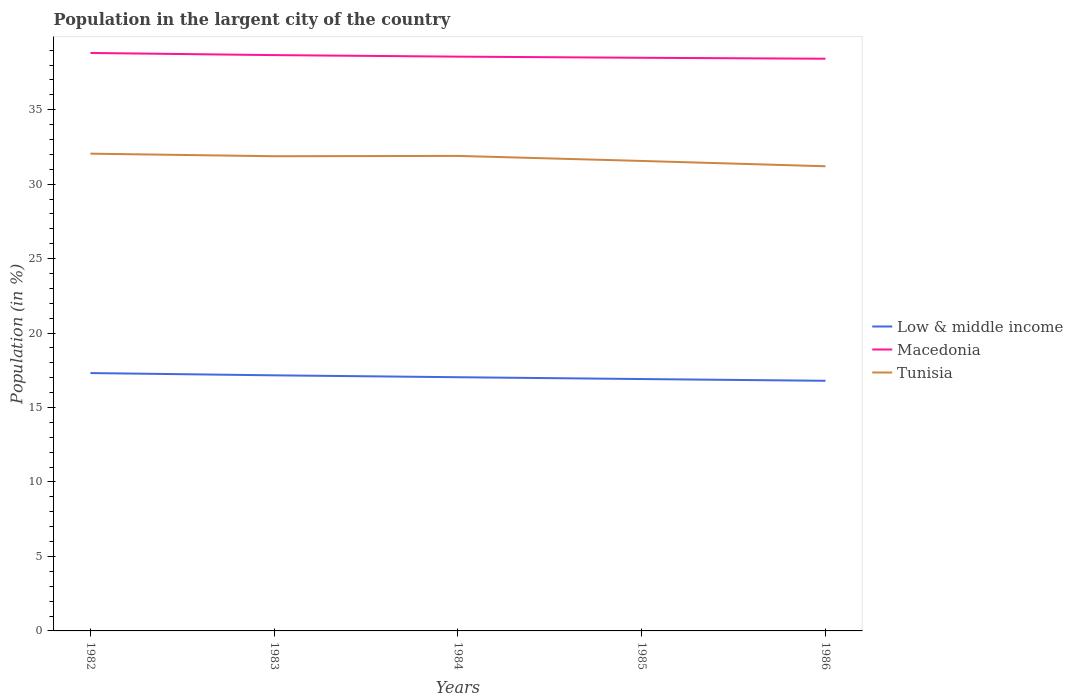Does the line corresponding to Low & middle income intersect with the line corresponding to Tunisia?
Keep it short and to the point. No. Is the number of lines equal to the number of legend labels?
Make the answer very short. Yes. Across all years, what is the maximum percentage of population in the largent city in Low & middle income?
Your answer should be very brief. 16.8. What is the total percentage of population in the largent city in Low & middle income in the graph?
Your answer should be very brief. 0.25. What is the difference between the highest and the second highest percentage of population in the largent city in Low & middle income?
Make the answer very short. 0.52. What is the difference between the highest and the lowest percentage of population in the largent city in Macedonia?
Keep it short and to the point. 2. Is the percentage of population in the largent city in Macedonia strictly greater than the percentage of population in the largent city in Low & middle income over the years?
Provide a succinct answer. No. Are the values on the major ticks of Y-axis written in scientific E-notation?
Ensure brevity in your answer.  No. What is the title of the graph?
Keep it short and to the point. Population in the largent city of the country. What is the label or title of the X-axis?
Ensure brevity in your answer.  Years. What is the label or title of the Y-axis?
Ensure brevity in your answer.  Population (in %). What is the Population (in %) of Low & middle income in 1982?
Provide a short and direct response. 17.31. What is the Population (in %) in Macedonia in 1982?
Make the answer very short. 38.81. What is the Population (in %) of Tunisia in 1982?
Keep it short and to the point. 32.05. What is the Population (in %) in Low & middle income in 1983?
Offer a terse response. 17.16. What is the Population (in %) in Macedonia in 1983?
Offer a very short reply. 38.66. What is the Population (in %) of Tunisia in 1983?
Your answer should be compact. 31.87. What is the Population (in %) in Low & middle income in 1984?
Keep it short and to the point. 17.04. What is the Population (in %) in Macedonia in 1984?
Provide a short and direct response. 38.56. What is the Population (in %) in Tunisia in 1984?
Give a very brief answer. 31.9. What is the Population (in %) of Low & middle income in 1985?
Provide a succinct answer. 16.91. What is the Population (in %) of Macedonia in 1985?
Give a very brief answer. 38.48. What is the Population (in %) in Tunisia in 1985?
Make the answer very short. 31.56. What is the Population (in %) of Low & middle income in 1986?
Give a very brief answer. 16.8. What is the Population (in %) in Macedonia in 1986?
Your response must be concise. 38.42. What is the Population (in %) of Tunisia in 1986?
Ensure brevity in your answer.  31.2. Across all years, what is the maximum Population (in %) of Low & middle income?
Ensure brevity in your answer.  17.31. Across all years, what is the maximum Population (in %) in Macedonia?
Provide a short and direct response. 38.81. Across all years, what is the maximum Population (in %) of Tunisia?
Ensure brevity in your answer.  32.05. Across all years, what is the minimum Population (in %) of Low & middle income?
Give a very brief answer. 16.8. Across all years, what is the minimum Population (in %) of Macedonia?
Ensure brevity in your answer.  38.42. Across all years, what is the minimum Population (in %) of Tunisia?
Provide a succinct answer. 31.2. What is the total Population (in %) of Low & middle income in the graph?
Offer a terse response. 85.22. What is the total Population (in %) of Macedonia in the graph?
Your answer should be very brief. 192.94. What is the total Population (in %) in Tunisia in the graph?
Provide a succinct answer. 158.57. What is the difference between the Population (in %) of Low & middle income in 1982 and that in 1983?
Your response must be concise. 0.15. What is the difference between the Population (in %) of Macedonia in 1982 and that in 1983?
Offer a very short reply. 0.14. What is the difference between the Population (in %) of Tunisia in 1982 and that in 1983?
Offer a terse response. 0.17. What is the difference between the Population (in %) in Low & middle income in 1982 and that in 1984?
Ensure brevity in your answer.  0.28. What is the difference between the Population (in %) of Macedonia in 1982 and that in 1984?
Make the answer very short. 0.25. What is the difference between the Population (in %) in Tunisia in 1982 and that in 1984?
Offer a very short reply. 0.15. What is the difference between the Population (in %) in Low & middle income in 1982 and that in 1985?
Your response must be concise. 0.4. What is the difference between the Population (in %) in Macedonia in 1982 and that in 1985?
Give a very brief answer. 0.32. What is the difference between the Population (in %) of Tunisia in 1982 and that in 1985?
Offer a terse response. 0.49. What is the difference between the Population (in %) in Low & middle income in 1982 and that in 1986?
Make the answer very short. 0.52. What is the difference between the Population (in %) of Macedonia in 1982 and that in 1986?
Give a very brief answer. 0.39. What is the difference between the Population (in %) in Tunisia in 1982 and that in 1986?
Your answer should be very brief. 0.85. What is the difference between the Population (in %) in Low & middle income in 1983 and that in 1984?
Ensure brevity in your answer.  0.13. What is the difference between the Population (in %) of Macedonia in 1983 and that in 1984?
Offer a terse response. 0.1. What is the difference between the Population (in %) in Tunisia in 1983 and that in 1984?
Offer a very short reply. -0.02. What is the difference between the Population (in %) in Low & middle income in 1983 and that in 1985?
Provide a succinct answer. 0.25. What is the difference between the Population (in %) in Macedonia in 1983 and that in 1985?
Your response must be concise. 0.18. What is the difference between the Population (in %) of Tunisia in 1983 and that in 1985?
Ensure brevity in your answer.  0.32. What is the difference between the Population (in %) in Low & middle income in 1983 and that in 1986?
Keep it short and to the point. 0.37. What is the difference between the Population (in %) in Macedonia in 1983 and that in 1986?
Your answer should be compact. 0.24. What is the difference between the Population (in %) in Tunisia in 1983 and that in 1986?
Offer a terse response. 0.67. What is the difference between the Population (in %) of Low & middle income in 1984 and that in 1985?
Your response must be concise. 0.12. What is the difference between the Population (in %) in Macedonia in 1984 and that in 1985?
Provide a short and direct response. 0.08. What is the difference between the Population (in %) in Tunisia in 1984 and that in 1985?
Provide a succinct answer. 0.34. What is the difference between the Population (in %) in Low & middle income in 1984 and that in 1986?
Make the answer very short. 0.24. What is the difference between the Population (in %) of Macedonia in 1984 and that in 1986?
Your response must be concise. 0.14. What is the difference between the Population (in %) in Tunisia in 1984 and that in 1986?
Your answer should be compact. 0.7. What is the difference between the Population (in %) in Low & middle income in 1985 and that in 1986?
Your answer should be compact. 0.12. What is the difference between the Population (in %) in Macedonia in 1985 and that in 1986?
Your response must be concise. 0.06. What is the difference between the Population (in %) in Tunisia in 1985 and that in 1986?
Offer a terse response. 0.36. What is the difference between the Population (in %) in Low & middle income in 1982 and the Population (in %) in Macedonia in 1983?
Give a very brief answer. -21.35. What is the difference between the Population (in %) of Low & middle income in 1982 and the Population (in %) of Tunisia in 1983?
Your response must be concise. -14.56. What is the difference between the Population (in %) in Macedonia in 1982 and the Population (in %) in Tunisia in 1983?
Give a very brief answer. 6.93. What is the difference between the Population (in %) in Low & middle income in 1982 and the Population (in %) in Macedonia in 1984?
Offer a very short reply. -21.25. What is the difference between the Population (in %) in Low & middle income in 1982 and the Population (in %) in Tunisia in 1984?
Ensure brevity in your answer.  -14.58. What is the difference between the Population (in %) in Macedonia in 1982 and the Population (in %) in Tunisia in 1984?
Keep it short and to the point. 6.91. What is the difference between the Population (in %) of Low & middle income in 1982 and the Population (in %) of Macedonia in 1985?
Your response must be concise. -21.17. What is the difference between the Population (in %) in Low & middle income in 1982 and the Population (in %) in Tunisia in 1985?
Your answer should be compact. -14.24. What is the difference between the Population (in %) of Macedonia in 1982 and the Population (in %) of Tunisia in 1985?
Give a very brief answer. 7.25. What is the difference between the Population (in %) of Low & middle income in 1982 and the Population (in %) of Macedonia in 1986?
Provide a short and direct response. -21.11. What is the difference between the Population (in %) in Low & middle income in 1982 and the Population (in %) in Tunisia in 1986?
Keep it short and to the point. -13.89. What is the difference between the Population (in %) of Macedonia in 1982 and the Population (in %) of Tunisia in 1986?
Your answer should be compact. 7.61. What is the difference between the Population (in %) in Low & middle income in 1983 and the Population (in %) in Macedonia in 1984?
Your response must be concise. -21.4. What is the difference between the Population (in %) of Low & middle income in 1983 and the Population (in %) of Tunisia in 1984?
Provide a succinct answer. -14.73. What is the difference between the Population (in %) of Macedonia in 1983 and the Population (in %) of Tunisia in 1984?
Provide a succinct answer. 6.77. What is the difference between the Population (in %) in Low & middle income in 1983 and the Population (in %) in Macedonia in 1985?
Keep it short and to the point. -21.32. What is the difference between the Population (in %) in Low & middle income in 1983 and the Population (in %) in Tunisia in 1985?
Make the answer very short. -14.4. What is the difference between the Population (in %) of Macedonia in 1983 and the Population (in %) of Tunisia in 1985?
Offer a very short reply. 7.11. What is the difference between the Population (in %) of Low & middle income in 1983 and the Population (in %) of Macedonia in 1986?
Your answer should be compact. -21.26. What is the difference between the Population (in %) in Low & middle income in 1983 and the Population (in %) in Tunisia in 1986?
Provide a short and direct response. -14.04. What is the difference between the Population (in %) in Macedonia in 1983 and the Population (in %) in Tunisia in 1986?
Keep it short and to the point. 7.46. What is the difference between the Population (in %) of Low & middle income in 1984 and the Population (in %) of Macedonia in 1985?
Offer a very short reply. -21.45. What is the difference between the Population (in %) in Low & middle income in 1984 and the Population (in %) in Tunisia in 1985?
Your answer should be compact. -14.52. What is the difference between the Population (in %) in Macedonia in 1984 and the Population (in %) in Tunisia in 1985?
Your answer should be compact. 7. What is the difference between the Population (in %) of Low & middle income in 1984 and the Population (in %) of Macedonia in 1986?
Ensure brevity in your answer.  -21.39. What is the difference between the Population (in %) in Low & middle income in 1984 and the Population (in %) in Tunisia in 1986?
Your response must be concise. -14.16. What is the difference between the Population (in %) of Macedonia in 1984 and the Population (in %) of Tunisia in 1986?
Provide a succinct answer. 7.36. What is the difference between the Population (in %) of Low & middle income in 1985 and the Population (in %) of Macedonia in 1986?
Your answer should be very brief. -21.51. What is the difference between the Population (in %) of Low & middle income in 1985 and the Population (in %) of Tunisia in 1986?
Your answer should be compact. -14.29. What is the difference between the Population (in %) of Macedonia in 1985 and the Population (in %) of Tunisia in 1986?
Give a very brief answer. 7.28. What is the average Population (in %) of Low & middle income per year?
Offer a terse response. 17.04. What is the average Population (in %) in Macedonia per year?
Give a very brief answer. 38.59. What is the average Population (in %) of Tunisia per year?
Make the answer very short. 31.71. In the year 1982, what is the difference between the Population (in %) of Low & middle income and Population (in %) of Macedonia?
Your answer should be very brief. -21.49. In the year 1982, what is the difference between the Population (in %) in Low & middle income and Population (in %) in Tunisia?
Offer a terse response. -14.73. In the year 1982, what is the difference between the Population (in %) of Macedonia and Population (in %) of Tunisia?
Give a very brief answer. 6.76. In the year 1983, what is the difference between the Population (in %) in Low & middle income and Population (in %) in Macedonia?
Give a very brief answer. -21.5. In the year 1983, what is the difference between the Population (in %) in Low & middle income and Population (in %) in Tunisia?
Your answer should be compact. -14.71. In the year 1983, what is the difference between the Population (in %) of Macedonia and Population (in %) of Tunisia?
Offer a terse response. 6.79. In the year 1984, what is the difference between the Population (in %) of Low & middle income and Population (in %) of Macedonia?
Your answer should be compact. -21.53. In the year 1984, what is the difference between the Population (in %) of Low & middle income and Population (in %) of Tunisia?
Provide a short and direct response. -14.86. In the year 1984, what is the difference between the Population (in %) in Macedonia and Population (in %) in Tunisia?
Offer a terse response. 6.67. In the year 1985, what is the difference between the Population (in %) of Low & middle income and Population (in %) of Macedonia?
Keep it short and to the point. -21.57. In the year 1985, what is the difference between the Population (in %) in Low & middle income and Population (in %) in Tunisia?
Offer a very short reply. -14.64. In the year 1985, what is the difference between the Population (in %) of Macedonia and Population (in %) of Tunisia?
Offer a terse response. 6.93. In the year 1986, what is the difference between the Population (in %) in Low & middle income and Population (in %) in Macedonia?
Provide a succinct answer. -21.63. In the year 1986, what is the difference between the Population (in %) of Low & middle income and Population (in %) of Tunisia?
Provide a short and direct response. -14.4. In the year 1986, what is the difference between the Population (in %) in Macedonia and Population (in %) in Tunisia?
Give a very brief answer. 7.22. What is the ratio of the Population (in %) of Low & middle income in 1982 to that in 1983?
Provide a short and direct response. 1.01. What is the ratio of the Population (in %) of Tunisia in 1982 to that in 1983?
Provide a succinct answer. 1.01. What is the ratio of the Population (in %) of Low & middle income in 1982 to that in 1984?
Provide a succinct answer. 1.02. What is the ratio of the Population (in %) of Macedonia in 1982 to that in 1984?
Give a very brief answer. 1.01. What is the ratio of the Population (in %) in Low & middle income in 1982 to that in 1985?
Offer a terse response. 1.02. What is the ratio of the Population (in %) in Macedonia in 1982 to that in 1985?
Your answer should be compact. 1.01. What is the ratio of the Population (in %) of Tunisia in 1982 to that in 1985?
Keep it short and to the point. 1.02. What is the ratio of the Population (in %) in Low & middle income in 1982 to that in 1986?
Ensure brevity in your answer.  1.03. What is the ratio of the Population (in %) of Tunisia in 1982 to that in 1986?
Give a very brief answer. 1.03. What is the ratio of the Population (in %) in Low & middle income in 1983 to that in 1984?
Give a very brief answer. 1.01. What is the ratio of the Population (in %) in Macedonia in 1983 to that in 1984?
Make the answer very short. 1. What is the ratio of the Population (in %) of Low & middle income in 1983 to that in 1985?
Make the answer very short. 1.01. What is the ratio of the Population (in %) of Low & middle income in 1983 to that in 1986?
Your response must be concise. 1.02. What is the ratio of the Population (in %) of Macedonia in 1983 to that in 1986?
Offer a very short reply. 1.01. What is the ratio of the Population (in %) of Tunisia in 1983 to that in 1986?
Provide a short and direct response. 1.02. What is the ratio of the Population (in %) of Low & middle income in 1984 to that in 1985?
Give a very brief answer. 1.01. What is the ratio of the Population (in %) in Macedonia in 1984 to that in 1985?
Offer a terse response. 1. What is the ratio of the Population (in %) in Tunisia in 1984 to that in 1985?
Your answer should be compact. 1.01. What is the ratio of the Population (in %) of Low & middle income in 1984 to that in 1986?
Ensure brevity in your answer.  1.01. What is the ratio of the Population (in %) of Tunisia in 1984 to that in 1986?
Offer a very short reply. 1.02. What is the ratio of the Population (in %) of Low & middle income in 1985 to that in 1986?
Offer a very short reply. 1.01. What is the ratio of the Population (in %) in Macedonia in 1985 to that in 1986?
Give a very brief answer. 1. What is the ratio of the Population (in %) of Tunisia in 1985 to that in 1986?
Your answer should be very brief. 1.01. What is the difference between the highest and the second highest Population (in %) of Low & middle income?
Offer a terse response. 0.15. What is the difference between the highest and the second highest Population (in %) of Macedonia?
Offer a terse response. 0.14. What is the difference between the highest and the second highest Population (in %) in Tunisia?
Your answer should be compact. 0.15. What is the difference between the highest and the lowest Population (in %) in Low & middle income?
Make the answer very short. 0.52. What is the difference between the highest and the lowest Population (in %) of Macedonia?
Keep it short and to the point. 0.39. What is the difference between the highest and the lowest Population (in %) of Tunisia?
Keep it short and to the point. 0.85. 